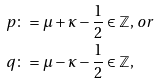Convert formula to latex. <formula><loc_0><loc_0><loc_500><loc_500>p & \colon = \mu + \kappa - \frac { 1 } { 2 } \in \mathbb { Z } , \, o r \\ q & \colon = \mu - \kappa - \frac { 1 } { 2 } \in \mathbb { Z } ,</formula> 